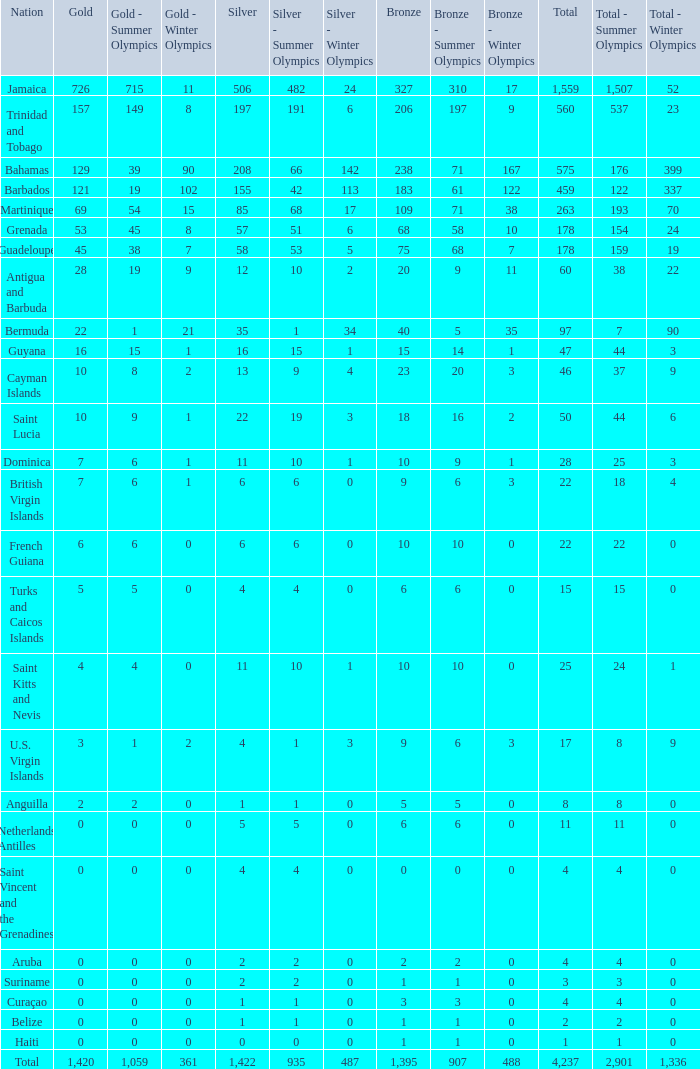What's the total number of Silver that has Gold that's larger than 0, Bronze that's smaller than 23, a Total that's larger than 22, and has the Nation of Saint Kitts and Nevis? 1.0. 